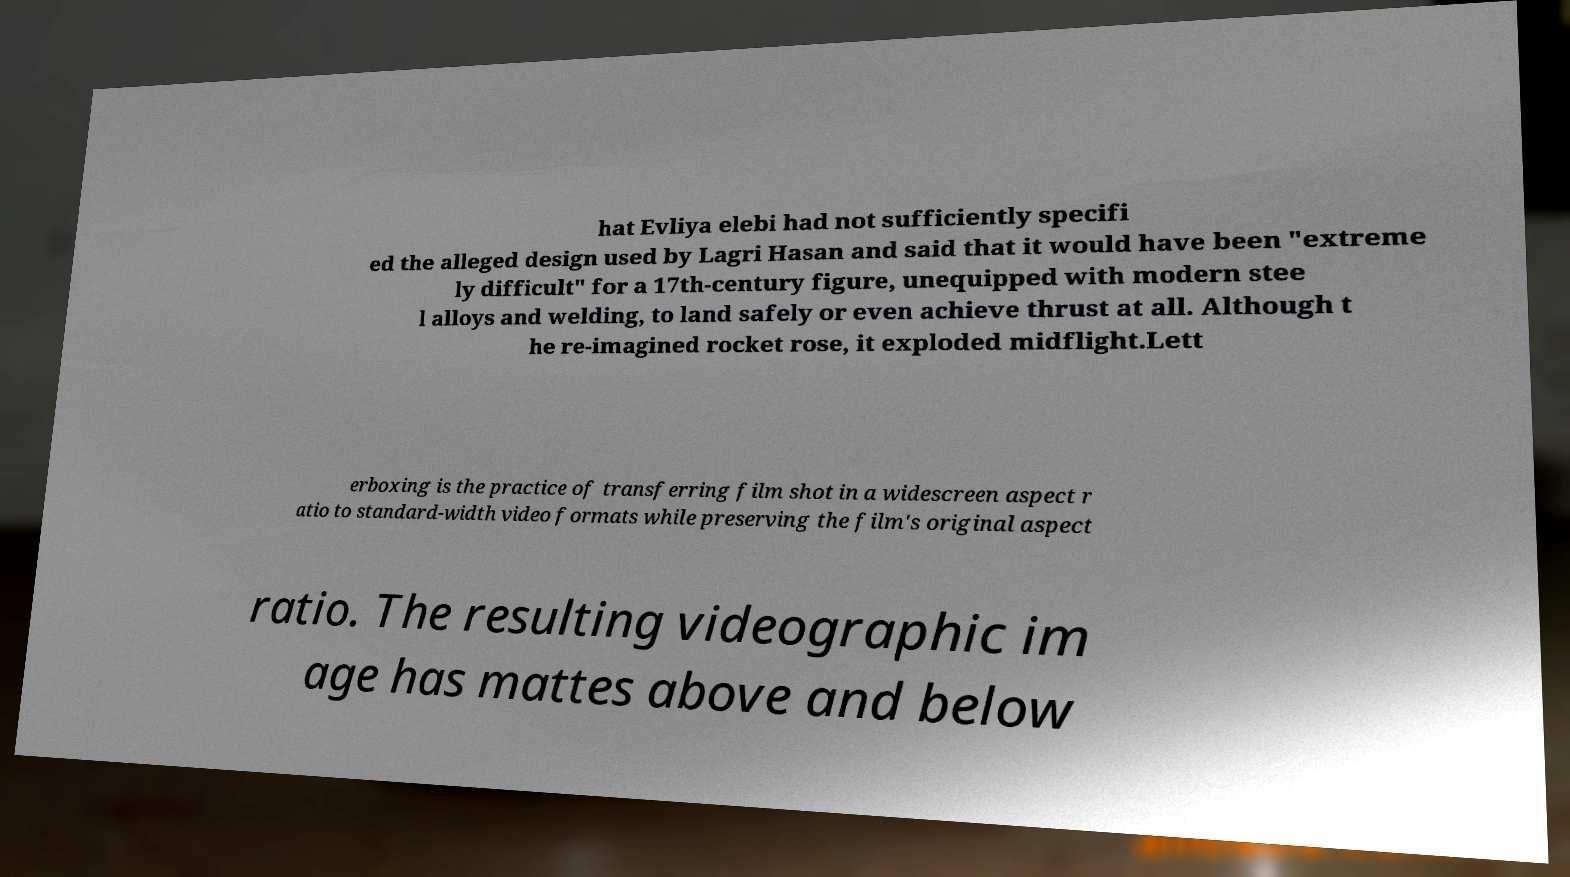There's text embedded in this image that I need extracted. Can you transcribe it verbatim? hat Evliya elebi had not sufficiently specifi ed the alleged design used by Lagri Hasan and said that it would have been "extreme ly difficult" for a 17th-century figure, unequipped with modern stee l alloys and welding, to land safely or even achieve thrust at all. Although t he re-imagined rocket rose, it exploded midflight.Lett erboxing is the practice of transferring film shot in a widescreen aspect r atio to standard-width video formats while preserving the film's original aspect ratio. The resulting videographic im age has mattes above and below 